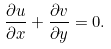<formula> <loc_0><loc_0><loc_500><loc_500>\frac { \partial u } { \partial x } + \frac { \partial v } { \partial y } = 0 .</formula> 